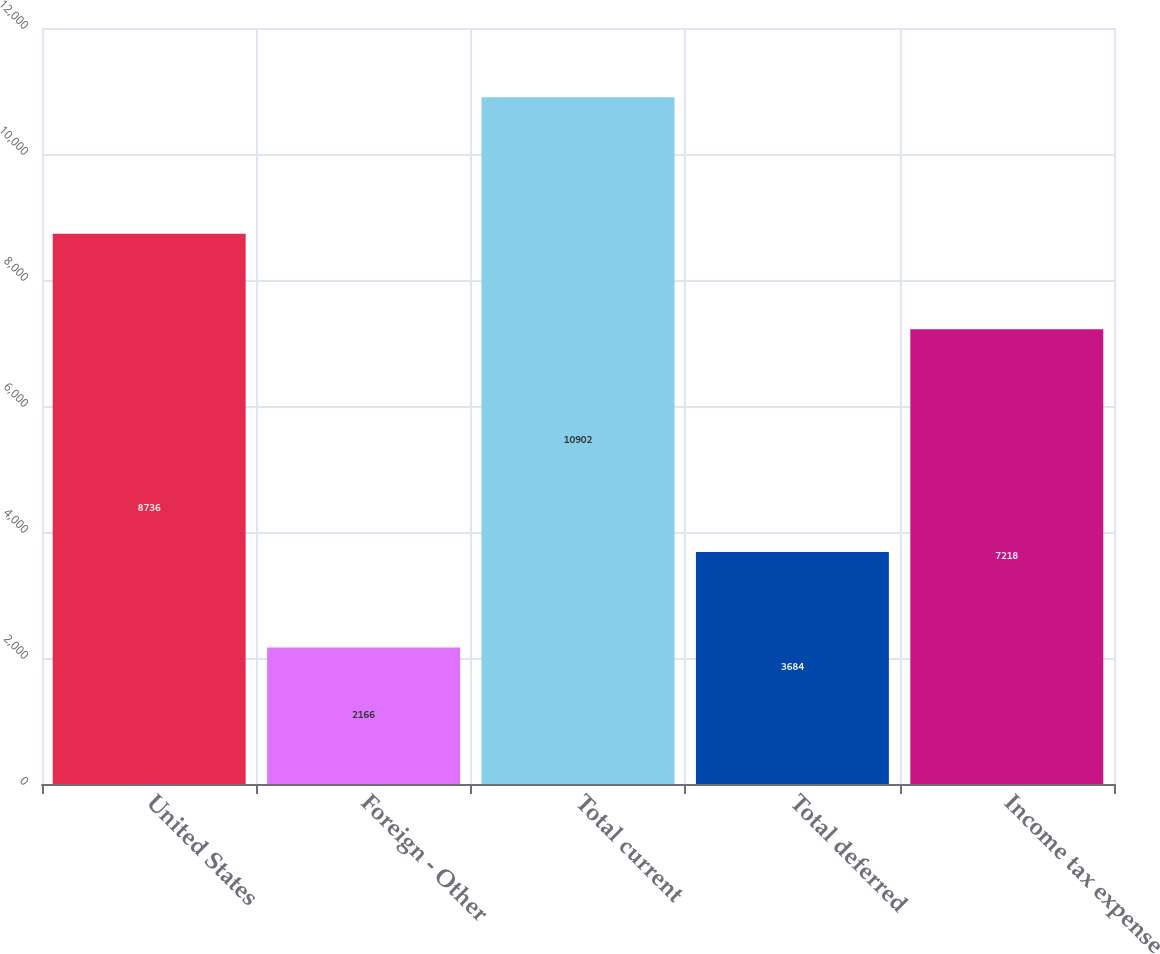Convert chart to OTSL. <chart><loc_0><loc_0><loc_500><loc_500><bar_chart><fcel>United States<fcel>Foreign - Other<fcel>Total current<fcel>Total deferred<fcel>Income tax expense<nl><fcel>8736<fcel>2166<fcel>10902<fcel>3684<fcel>7218<nl></chart> 